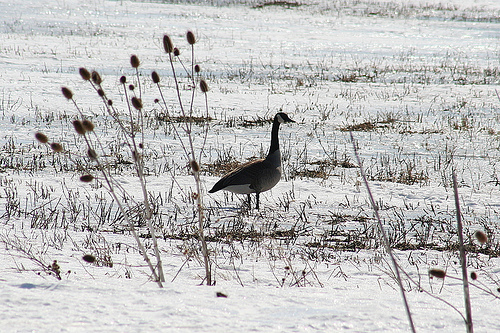<image>
Is the goose on the wetland? Yes. Looking at the image, I can see the goose is positioned on top of the wetland, with the wetland providing support. 